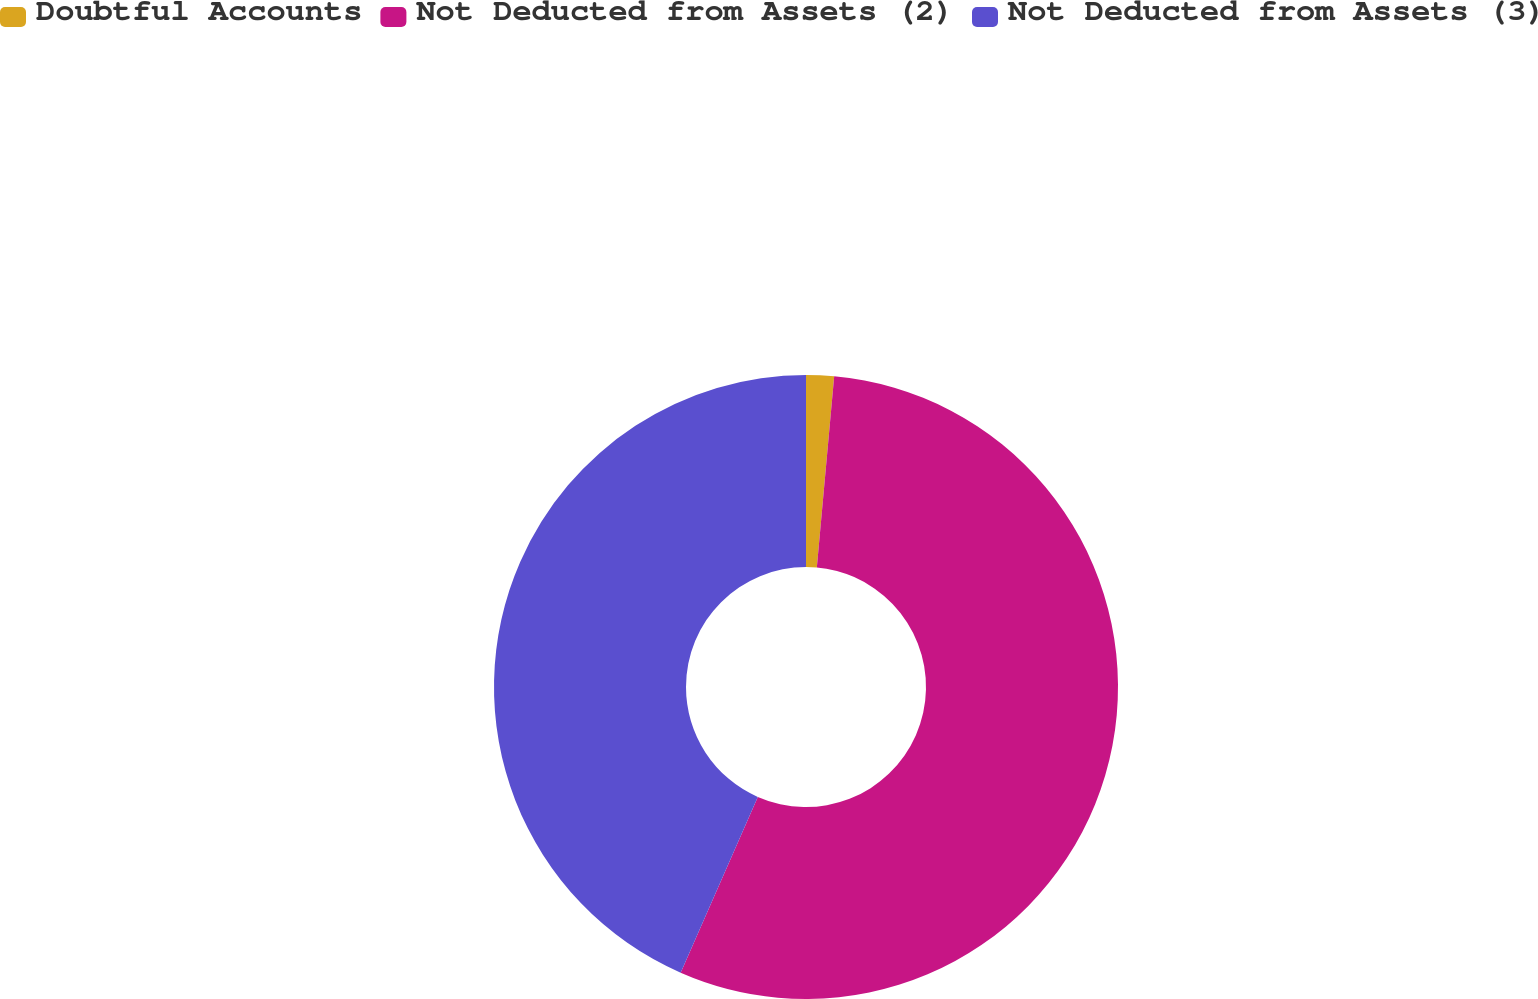Convert chart. <chart><loc_0><loc_0><loc_500><loc_500><pie_chart><fcel>Doubtful Accounts<fcel>Not Deducted from Assets (2)<fcel>Not Deducted from Assets (3)<nl><fcel>1.44%<fcel>55.14%<fcel>43.42%<nl></chart> 